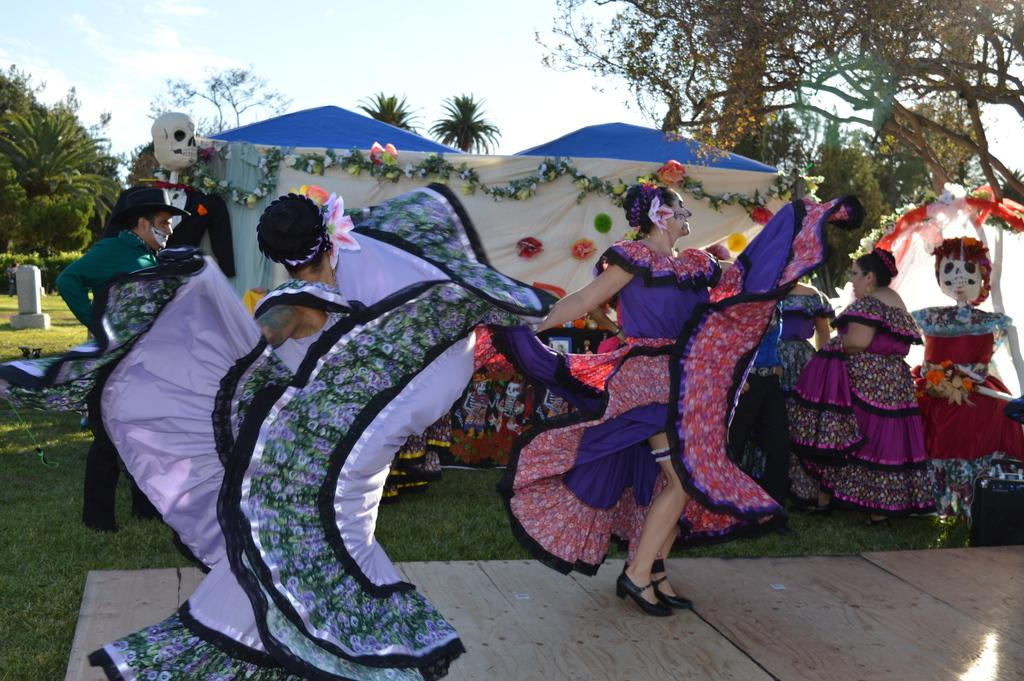What are the people in the image wearing? The people in the image are wearing costumes. What type of surface is at the bottom of the image? There is a wooden floor and grass at the bottom of the image. What can be seen in the background of the image? There are trees and the sky visible in the background of the image. What type of linen is draped over the chairs in the image? There are no chairs or linen present in the image. What might surprise the people in the image? It is impossible to determine what might surprise the people in the image based on the provided facts. 